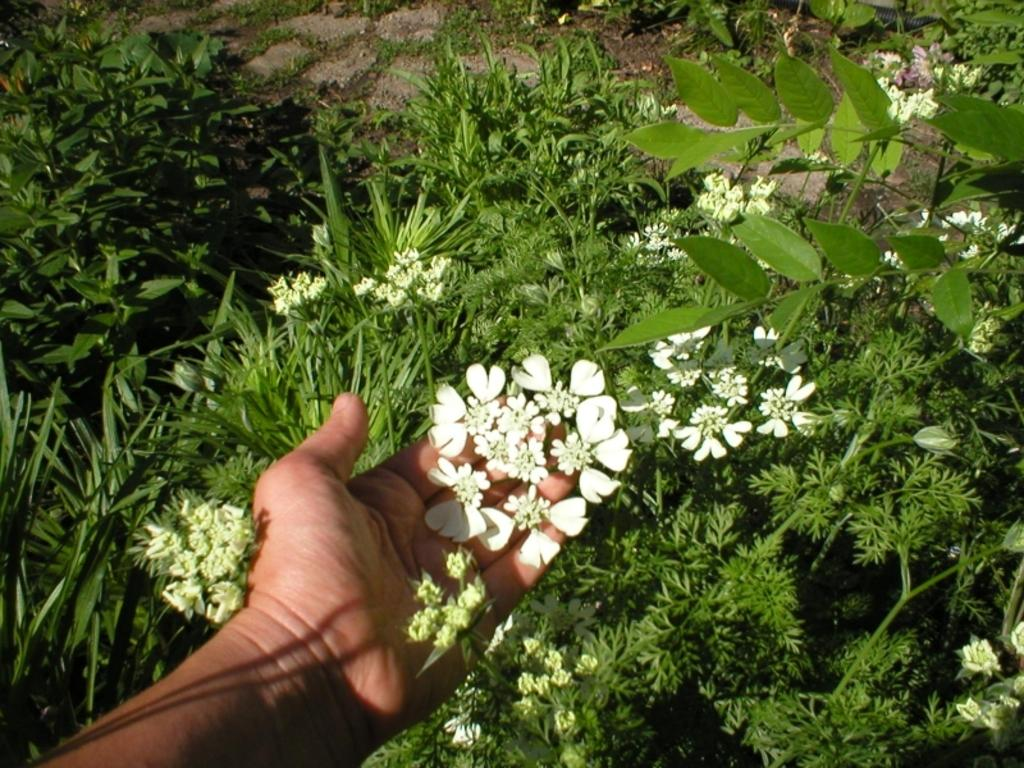Who or what is present in the image? There is a person in the image. What is the person holding? The person is holding flowers. Can you describe any body parts visible in the image? A human hand is visible in the image. What type of environment is depicted in the image? There is grass and plants in the image, suggesting an outdoor setting. What type of bread can be seen in the image? There is no bread present in the image. Can you describe the window in the image? There is no window present in the image. 